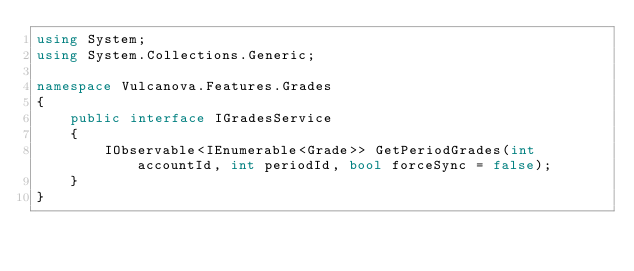<code> <loc_0><loc_0><loc_500><loc_500><_C#_>using System;
using System.Collections.Generic;

namespace Vulcanova.Features.Grades
{
    public interface IGradesService
    {
        IObservable<IEnumerable<Grade>> GetPeriodGrades(int accountId, int periodId, bool forceSync = false);
    }
}</code> 